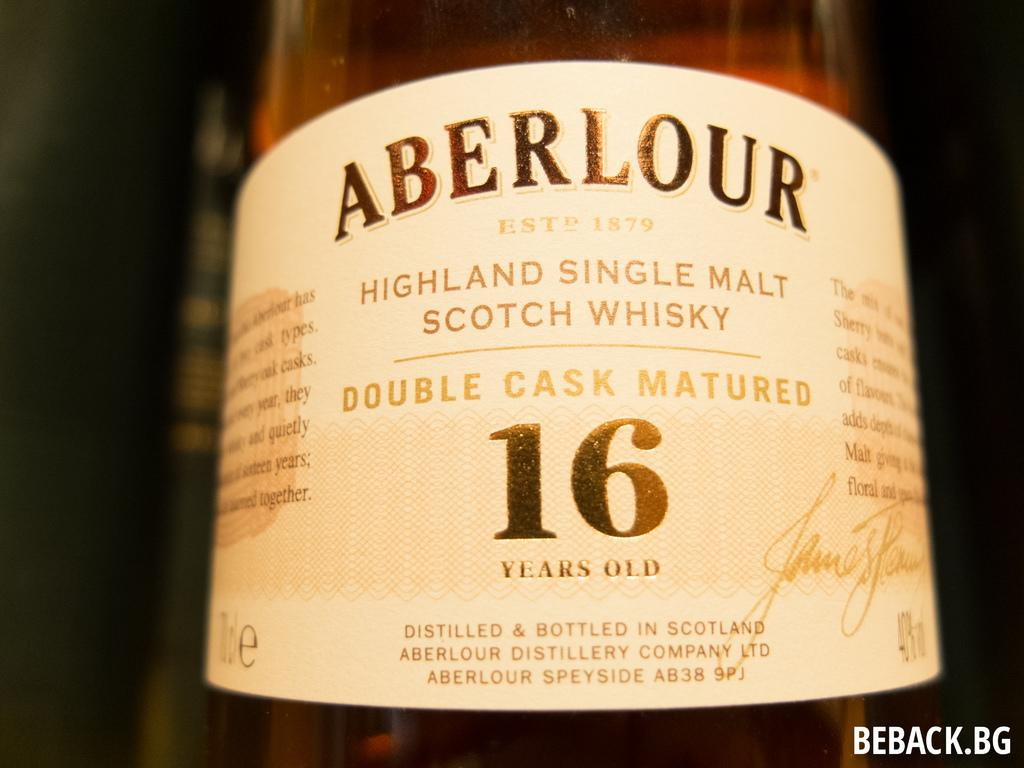<image>
Give a short and clear explanation of the subsequent image. A bottle of Scotch whisky has Aberlour logo on it. 